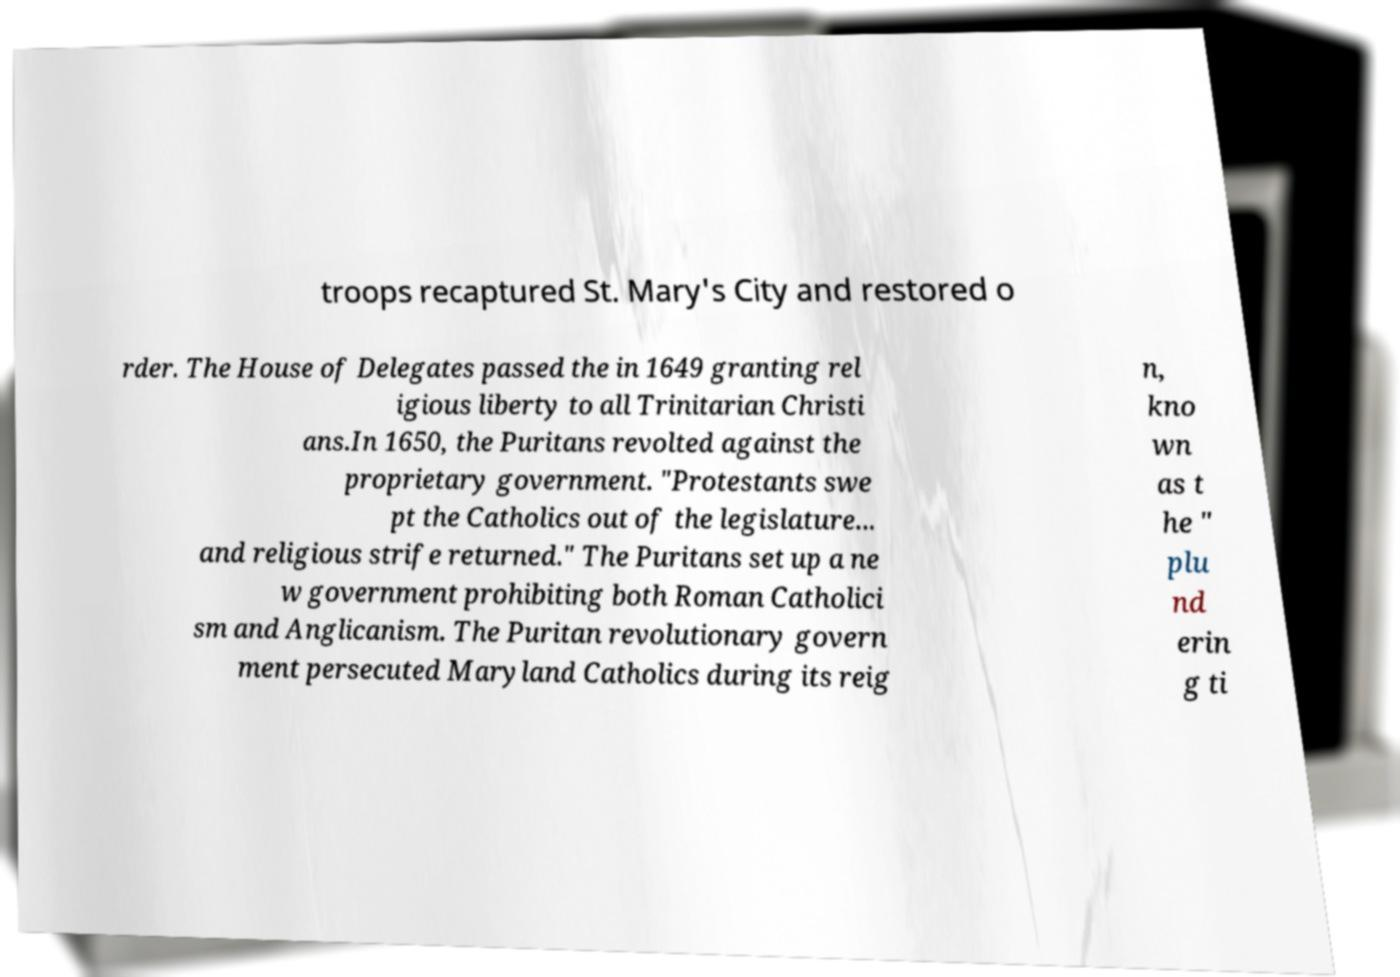Please read and relay the text visible in this image. What does it say? troops recaptured St. Mary's City and restored o rder. The House of Delegates passed the in 1649 granting rel igious liberty to all Trinitarian Christi ans.In 1650, the Puritans revolted against the proprietary government. "Protestants swe pt the Catholics out of the legislature... and religious strife returned." The Puritans set up a ne w government prohibiting both Roman Catholici sm and Anglicanism. The Puritan revolutionary govern ment persecuted Maryland Catholics during its reig n, kno wn as t he " plu nd erin g ti 